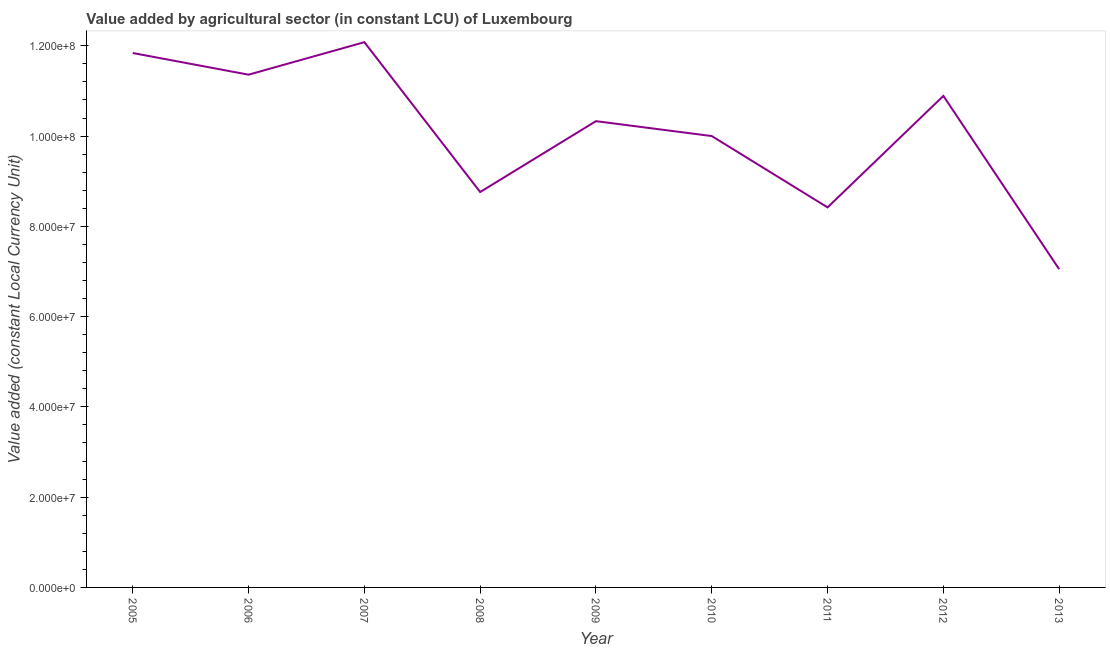What is the value added by agriculture sector in 2009?
Ensure brevity in your answer.  1.03e+08. Across all years, what is the maximum value added by agriculture sector?
Provide a succinct answer. 1.21e+08. Across all years, what is the minimum value added by agriculture sector?
Make the answer very short. 7.05e+07. In which year was the value added by agriculture sector minimum?
Your answer should be compact. 2013. What is the sum of the value added by agriculture sector?
Provide a succinct answer. 9.07e+08. What is the difference between the value added by agriculture sector in 2010 and 2011?
Offer a terse response. 1.58e+07. What is the average value added by agriculture sector per year?
Keep it short and to the point. 1.01e+08. What is the median value added by agriculture sector?
Offer a terse response. 1.03e+08. Do a majority of the years between 2007 and 2008 (inclusive) have value added by agriculture sector greater than 88000000 LCU?
Your answer should be very brief. No. What is the ratio of the value added by agriculture sector in 2009 to that in 2010?
Your answer should be very brief. 1.03. Is the difference between the value added by agriculture sector in 2006 and 2011 greater than the difference between any two years?
Provide a short and direct response. No. What is the difference between the highest and the second highest value added by agriculture sector?
Give a very brief answer. 2.40e+06. What is the difference between the highest and the lowest value added by agriculture sector?
Make the answer very short. 5.03e+07. How many years are there in the graph?
Your answer should be very brief. 9. Are the values on the major ticks of Y-axis written in scientific E-notation?
Give a very brief answer. Yes. Does the graph contain grids?
Provide a succinct answer. No. What is the title of the graph?
Provide a short and direct response. Value added by agricultural sector (in constant LCU) of Luxembourg. What is the label or title of the Y-axis?
Your response must be concise. Value added (constant Local Currency Unit). What is the Value added (constant Local Currency Unit) of 2005?
Keep it short and to the point. 1.18e+08. What is the Value added (constant Local Currency Unit) in 2006?
Offer a very short reply. 1.14e+08. What is the Value added (constant Local Currency Unit) in 2007?
Your response must be concise. 1.21e+08. What is the Value added (constant Local Currency Unit) of 2008?
Provide a succinct answer. 8.76e+07. What is the Value added (constant Local Currency Unit) of 2009?
Your answer should be very brief. 1.03e+08. What is the Value added (constant Local Currency Unit) of 2010?
Give a very brief answer. 1.00e+08. What is the Value added (constant Local Currency Unit) of 2011?
Give a very brief answer. 8.42e+07. What is the Value added (constant Local Currency Unit) in 2012?
Offer a very short reply. 1.09e+08. What is the Value added (constant Local Currency Unit) in 2013?
Make the answer very short. 7.05e+07. What is the difference between the Value added (constant Local Currency Unit) in 2005 and 2006?
Make the answer very short. 4.80e+06. What is the difference between the Value added (constant Local Currency Unit) in 2005 and 2007?
Offer a very short reply. -2.40e+06. What is the difference between the Value added (constant Local Currency Unit) in 2005 and 2008?
Provide a short and direct response. 3.08e+07. What is the difference between the Value added (constant Local Currency Unit) in 2005 and 2009?
Give a very brief answer. 1.51e+07. What is the difference between the Value added (constant Local Currency Unit) in 2005 and 2010?
Offer a very short reply. 1.84e+07. What is the difference between the Value added (constant Local Currency Unit) in 2005 and 2011?
Your answer should be compact. 3.42e+07. What is the difference between the Value added (constant Local Currency Unit) in 2005 and 2012?
Your response must be concise. 9.50e+06. What is the difference between the Value added (constant Local Currency Unit) in 2005 and 2013?
Your answer should be compact. 4.79e+07. What is the difference between the Value added (constant Local Currency Unit) in 2006 and 2007?
Your answer should be very brief. -7.20e+06. What is the difference between the Value added (constant Local Currency Unit) in 2006 and 2008?
Offer a very short reply. 2.60e+07. What is the difference between the Value added (constant Local Currency Unit) in 2006 and 2009?
Your answer should be very brief. 1.03e+07. What is the difference between the Value added (constant Local Currency Unit) in 2006 and 2010?
Keep it short and to the point. 1.36e+07. What is the difference between the Value added (constant Local Currency Unit) in 2006 and 2011?
Provide a succinct answer. 2.94e+07. What is the difference between the Value added (constant Local Currency Unit) in 2006 and 2012?
Provide a short and direct response. 4.70e+06. What is the difference between the Value added (constant Local Currency Unit) in 2006 and 2013?
Give a very brief answer. 4.31e+07. What is the difference between the Value added (constant Local Currency Unit) in 2007 and 2008?
Provide a short and direct response. 3.32e+07. What is the difference between the Value added (constant Local Currency Unit) in 2007 and 2009?
Offer a very short reply. 1.75e+07. What is the difference between the Value added (constant Local Currency Unit) in 2007 and 2010?
Ensure brevity in your answer.  2.08e+07. What is the difference between the Value added (constant Local Currency Unit) in 2007 and 2011?
Offer a very short reply. 3.66e+07. What is the difference between the Value added (constant Local Currency Unit) in 2007 and 2012?
Keep it short and to the point. 1.19e+07. What is the difference between the Value added (constant Local Currency Unit) in 2007 and 2013?
Your answer should be very brief. 5.03e+07. What is the difference between the Value added (constant Local Currency Unit) in 2008 and 2009?
Offer a terse response. -1.57e+07. What is the difference between the Value added (constant Local Currency Unit) in 2008 and 2010?
Your answer should be compact. -1.24e+07. What is the difference between the Value added (constant Local Currency Unit) in 2008 and 2011?
Offer a very short reply. 3.40e+06. What is the difference between the Value added (constant Local Currency Unit) in 2008 and 2012?
Provide a short and direct response. -2.13e+07. What is the difference between the Value added (constant Local Currency Unit) in 2008 and 2013?
Keep it short and to the point. 1.71e+07. What is the difference between the Value added (constant Local Currency Unit) in 2009 and 2010?
Provide a succinct answer. 3.30e+06. What is the difference between the Value added (constant Local Currency Unit) in 2009 and 2011?
Ensure brevity in your answer.  1.91e+07. What is the difference between the Value added (constant Local Currency Unit) in 2009 and 2012?
Offer a very short reply. -5.60e+06. What is the difference between the Value added (constant Local Currency Unit) in 2009 and 2013?
Keep it short and to the point. 3.28e+07. What is the difference between the Value added (constant Local Currency Unit) in 2010 and 2011?
Offer a terse response. 1.58e+07. What is the difference between the Value added (constant Local Currency Unit) in 2010 and 2012?
Your answer should be very brief. -8.90e+06. What is the difference between the Value added (constant Local Currency Unit) in 2010 and 2013?
Your response must be concise. 2.95e+07. What is the difference between the Value added (constant Local Currency Unit) in 2011 and 2012?
Offer a terse response. -2.47e+07. What is the difference between the Value added (constant Local Currency Unit) in 2011 and 2013?
Give a very brief answer. 1.37e+07. What is the difference between the Value added (constant Local Currency Unit) in 2012 and 2013?
Keep it short and to the point. 3.84e+07. What is the ratio of the Value added (constant Local Currency Unit) in 2005 to that in 2006?
Offer a terse response. 1.04. What is the ratio of the Value added (constant Local Currency Unit) in 2005 to that in 2007?
Keep it short and to the point. 0.98. What is the ratio of the Value added (constant Local Currency Unit) in 2005 to that in 2008?
Your answer should be compact. 1.35. What is the ratio of the Value added (constant Local Currency Unit) in 2005 to that in 2009?
Provide a succinct answer. 1.15. What is the ratio of the Value added (constant Local Currency Unit) in 2005 to that in 2010?
Offer a very short reply. 1.18. What is the ratio of the Value added (constant Local Currency Unit) in 2005 to that in 2011?
Your response must be concise. 1.41. What is the ratio of the Value added (constant Local Currency Unit) in 2005 to that in 2012?
Your answer should be compact. 1.09. What is the ratio of the Value added (constant Local Currency Unit) in 2005 to that in 2013?
Your response must be concise. 1.68. What is the ratio of the Value added (constant Local Currency Unit) in 2006 to that in 2008?
Ensure brevity in your answer.  1.3. What is the ratio of the Value added (constant Local Currency Unit) in 2006 to that in 2010?
Make the answer very short. 1.14. What is the ratio of the Value added (constant Local Currency Unit) in 2006 to that in 2011?
Keep it short and to the point. 1.35. What is the ratio of the Value added (constant Local Currency Unit) in 2006 to that in 2012?
Provide a succinct answer. 1.04. What is the ratio of the Value added (constant Local Currency Unit) in 2006 to that in 2013?
Offer a very short reply. 1.61. What is the ratio of the Value added (constant Local Currency Unit) in 2007 to that in 2008?
Your answer should be very brief. 1.38. What is the ratio of the Value added (constant Local Currency Unit) in 2007 to that in 2009?
Offer a very short reply. 1.17. What is the ratio of the Value added (constant Local Currency Unit) in 2007 to that in 2010?
Your answer should be very brief. 1.21. What is the ratio of the Value added (constant Local Currency Unit) in 2007 to that in 2011?
Give a very brief answer. 1.44. What is the ratio of the Value added (constant Local Currency Unit) in 2007 to that in 2012?
Provide a succinct answer. 1.11. What is the ratio of the Value added (constant Local Currency Unit) in 2007 to that in 2013?
Offer a terse response. 1.71. What is the ratio of the Value added (constant Local Currency Unit) in 2008 to that in 2009?
Your response must be concise. 0.85. What is the ratio of the Value added (constant Local Currency Unit) in 2008 to that in 2010?
Offer a very short reply. 0.88. What is the ratio of the Value added (constant Local Currency Unit) in 2008 to that in 2011?
Keep it short and to the point. 1.04. What is the ratio of the Value added (constant Local Currency Unit) in 2008 to that in 2012?
Keep it short and to the point. 0.8. What is the ratio of the Value added (constant Local Currency Unit) in 2008 to that in 2013?
Make the answer very short. 1.24. What is the ratio of the Value added (constant Local Currency Unit) in 2009 to that in 2010?
Ensure brevity in your answer.  1.03. What is the ratio of the Value added (constant Local Currency Unit) in 2009 to that in 2011?
Provide a short and direct response. 1.23. What is the ratio of the Value added (constant Local Currency Unit) in 2009 to that in 2012?
Give a very brief answer. 0.95. What is the ratio of the Value added (constant Local Currency Unit) in 2009 to that in 2013?
Provide a short and direct response. 1.47. What is the ratio of the Value added (constant Local Currency Unit) in 2010 to that in 2011?
Give a very brief answer. 1.19. What is the ratio of the Value added (constant Local Currency Unit) in 2010 to that in 2012?
Your response must be concise. 0.92. What is the ratio of the Value added (constant Local Currency Unit) in 2010 to that in 2013?
Your answer should be compact. 1.42. What is the ratio of the Value added (constant Local Currency Unit) in 2011 to that in 2012?
Make the answer very short. 0.77. What is the ratio of the Value added (constant Local Currency Unit) in 2011 to that in 2013?
Offer a terse response. 1.19. What is the ratio of the Value added (constant Local Currency Unit) in 2012 to that in 2013?
Your answer should be compact. 1.54. 